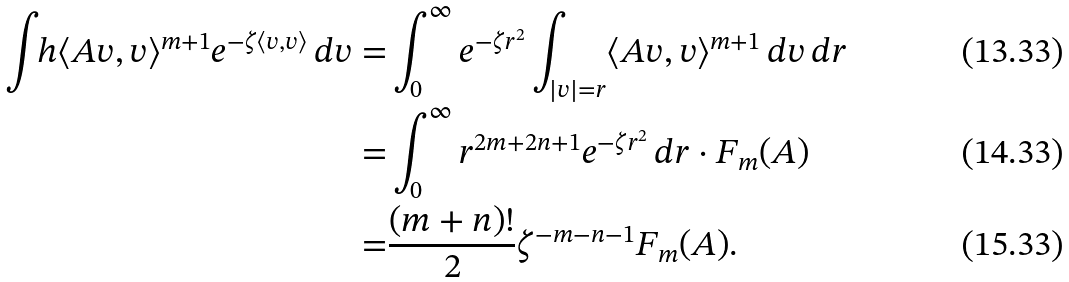<formula> <loc_0><loc_0><loc_500><loc_500>\int _ { \ } h \langle A v , v \rangle ^ { m + 1 } e ^ { - \zeta \langle v , v \rangle } \, d v = & \int _ { 0 } ^ { \infty } e ^ { - \zeta r ^ { 2 } } \int _ { | v | = r } \langle A v , v \rangle ^ { m + 1 } \, d v \, d r \\ = & \int _ { 0 } ^ { \infty } r ^ { 2 m + 2 n + 1 } e ^ { - \zeta r ^ { 2 } } \, d r \cdot F _ { m } ( A ) \\ = & \frac { ( m + n ) ! } { 2 } \zeta ^ { - m - n - 1 } F _ { m } ( A ) .</formula> 